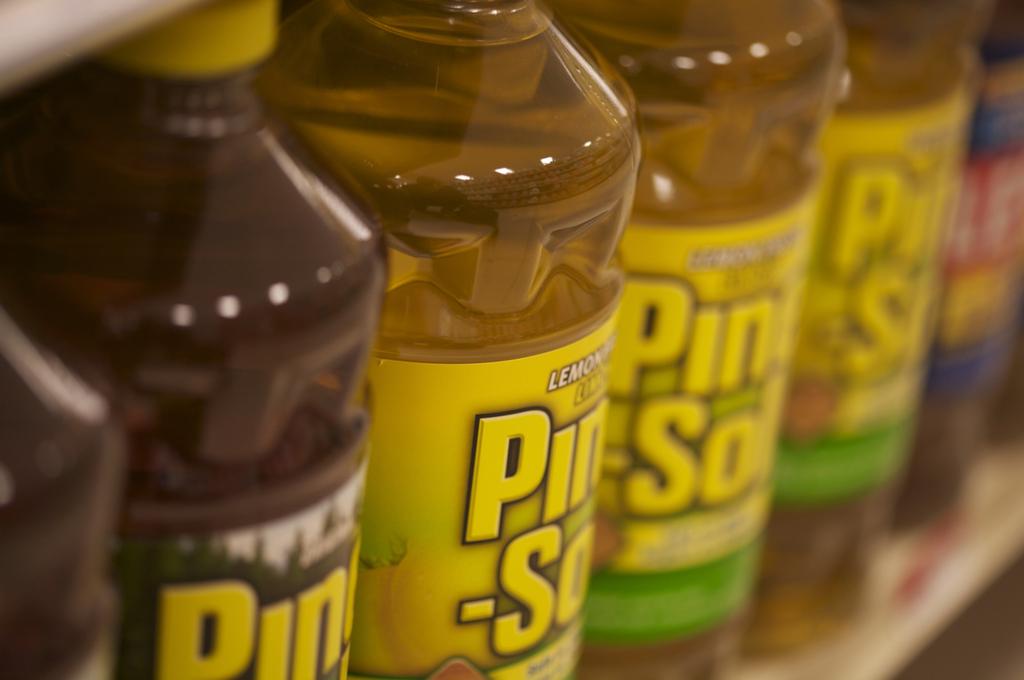What scent is this household cleaner?
Keep it short and to the point. Lemon. What is the name of the lemon scent product?
Ensure brevity in your answer.  Pine sol. 